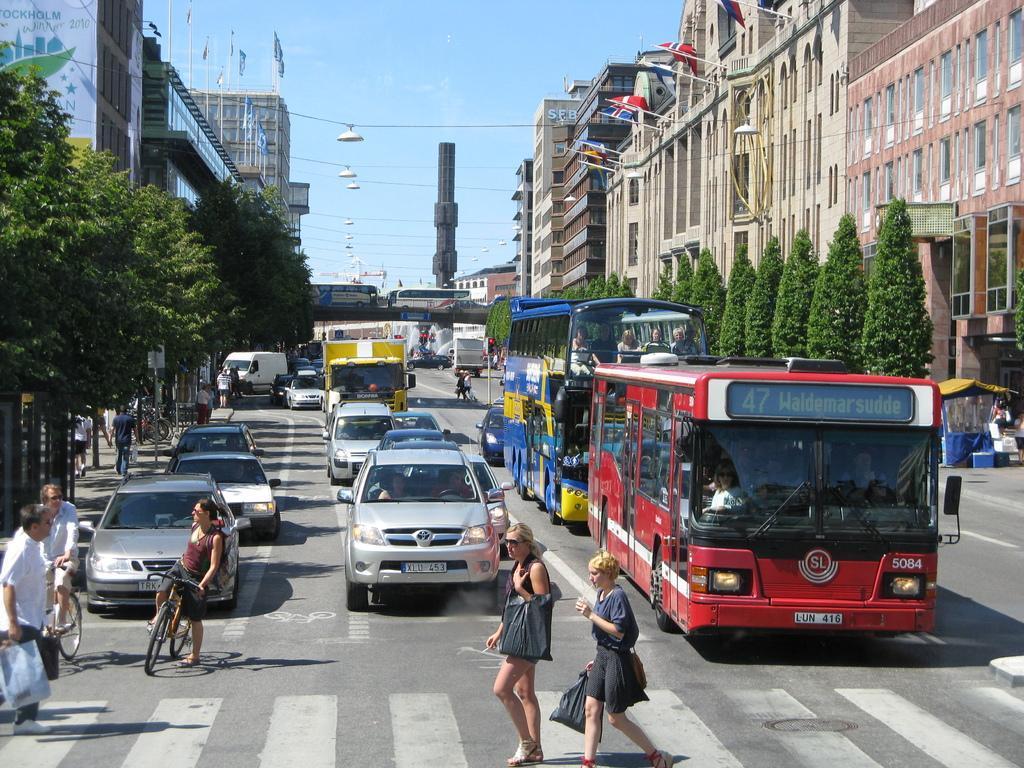Please provide a concise description of this image. Here in the front we can see a couple of woman walking through the zebra crossing and behind them we can see a bus and cars waiting near the signal and here at the left side we can see a woman on a bicycle and there are trees and buildings present 